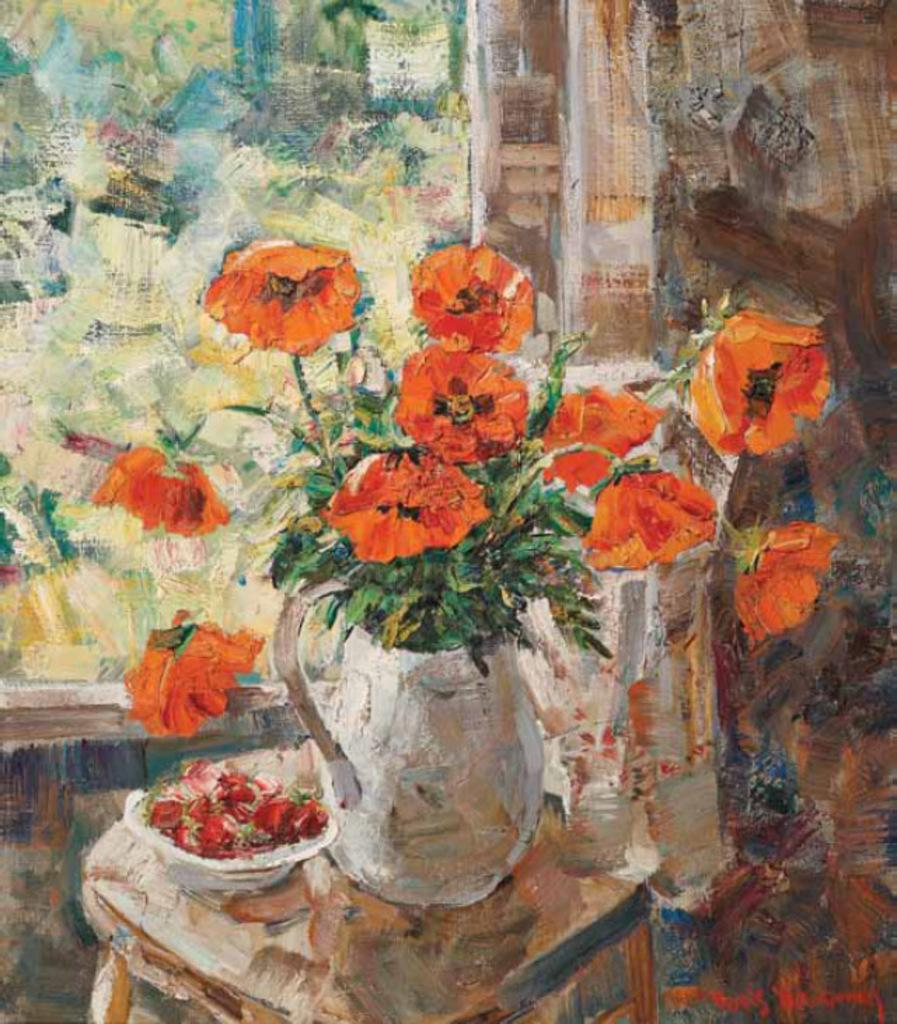What is depicted in the painting in the image? There is a painting of a flower vase in the image. What type of flowers are in the vase? The flower vase contains orange flowers. Where are the flowers and the painting located? The flowers are on a table, and the painting is likely on a wall or another surface. What else related to flowers can be seen in the image? There is a bowl full of flower petals in the image. What type of yarn is being used to create the hydrant in the image? There is no hydrant or yarn present in the image; it features a painting of a flower vase with orange flowers on a table and a bowl full of flower petals. 